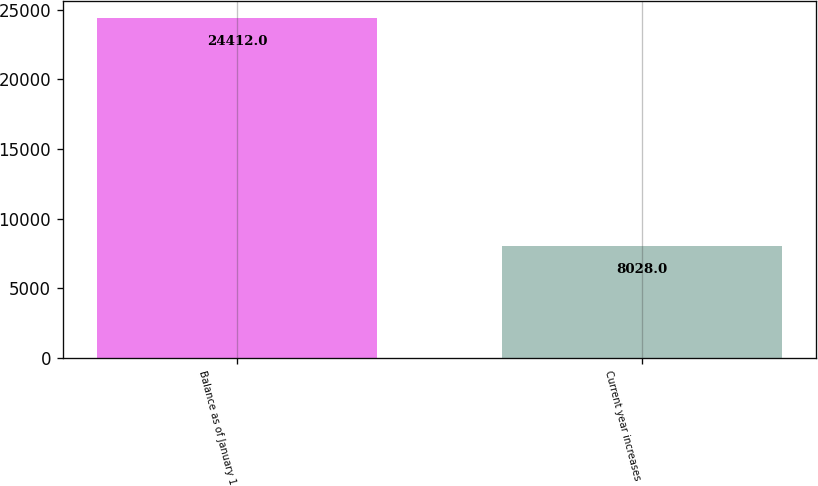<chart> <loc_0><loc_0><loc_500><loc_500><bar_chart><fcel>Balance as of January 1<fcel>Current year increases<nl><fcel>24412<fcel>8028<nl></chart> 